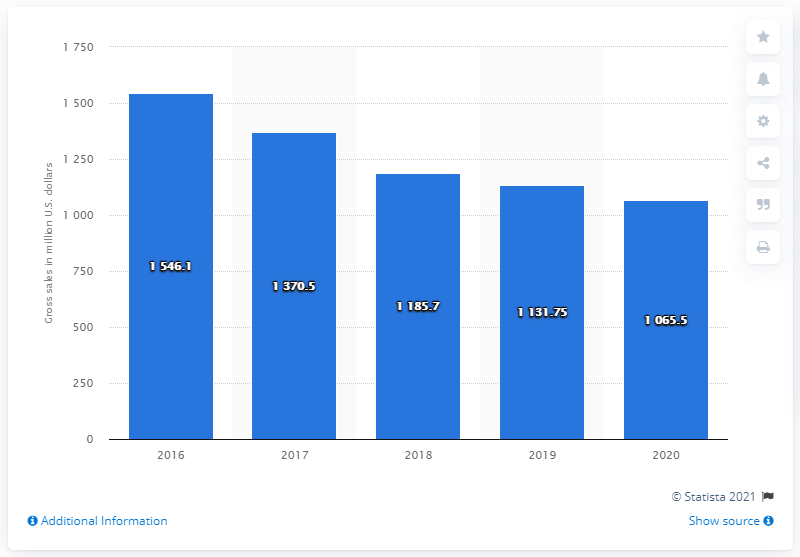Give some essential details in this illustration. The gross sales of Mattel's Fisher-Price and Thomas & Friends brands totaled 1065.5 in 2020. 